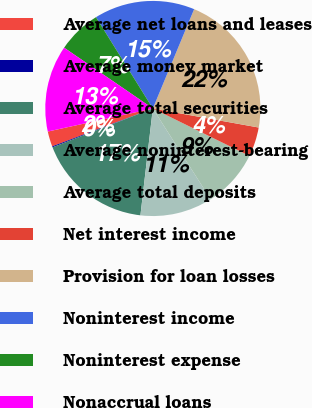Convert chart. <chart><loc_0><loc_0><loc_500><loc_500><pie_chart><fcel>Average net loans and leases<fcel>Average money market<fcel>Average total securities<fcel>Average noninterest-bearing<fcel>Average total deposits<fcel>Net interest income<fcel>Provision for loan losses<fcel>Noninterest income<fcel>Noninterest expense<fcel>Nonaccrual loans<nl><fcel>2.29%<fcel>0.15%<fcel>17.28%<fcel>10.86%<fcel>8.72%<fcel>4.43%<fcel>21.56%<fcel>15.14%<fcel>6.57%<fcel>13.0%<nl></chart> 